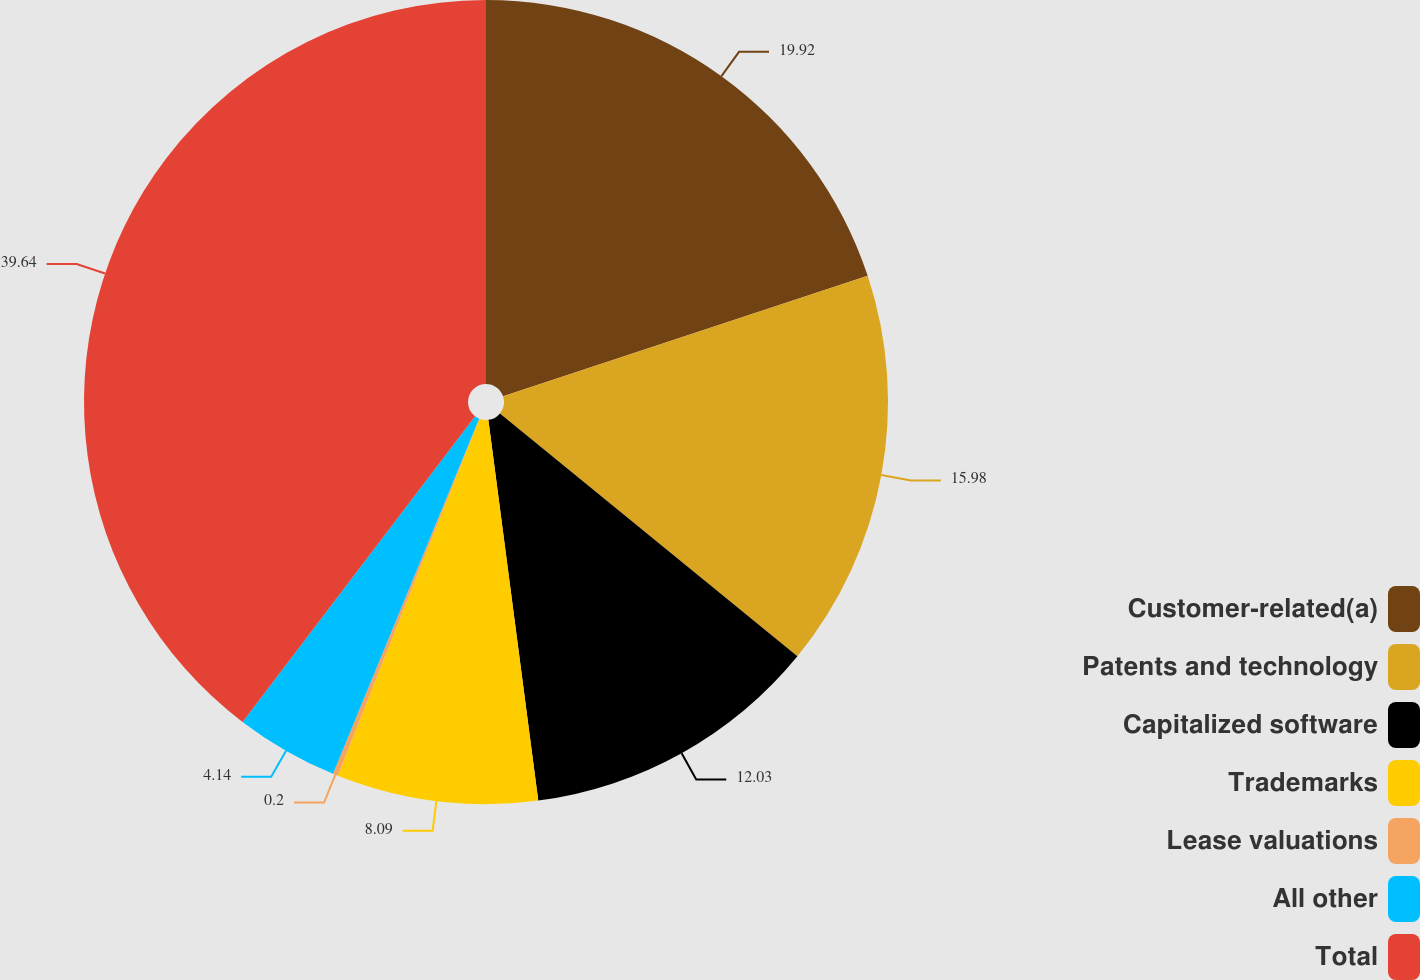<chart> <loc_0><loc_0><loc_500><loc_500><pie_chart><fcel>Customer-related(a)<fcel>Patents and technology<fcel>Capitalized software<fcel>Trademarks<fcel>Lease valuations<fcel>All other<fcel>Total<nl><fcel>19.92%<fcel>15.98%<fcel>12.03%<fcel>8.09%<fcel>0.2%<fcel>4.14%<fcel>39.65%<nl></chart> 